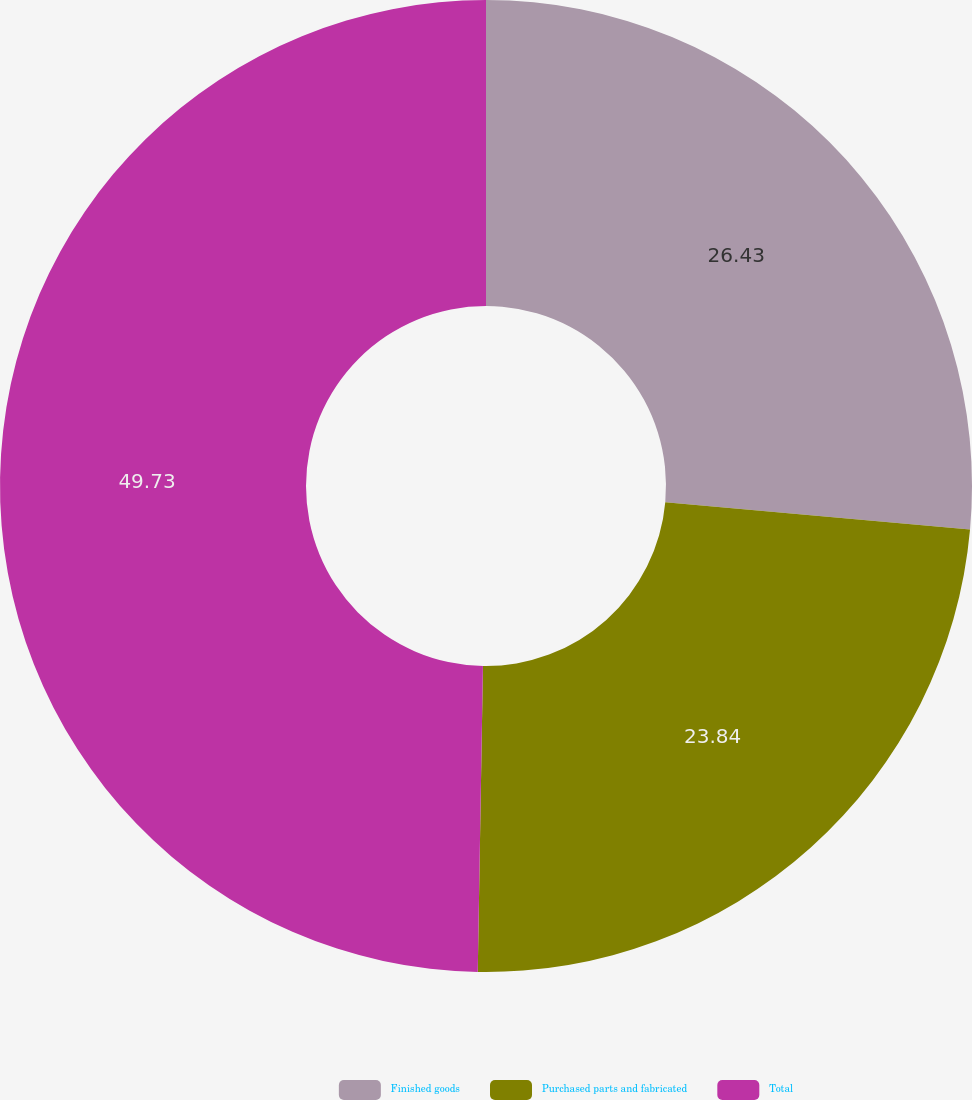Convert chart to OTSL. <chart><loc_0><loc_0><loc_500><loc_500><pie_chart><fcel>Finished goods<fcel>Purchased parts and fabricated<fcel>Total<nl><fcel>26.43%<fcel>23.84%<fcel>49.73%<nl></chart> 